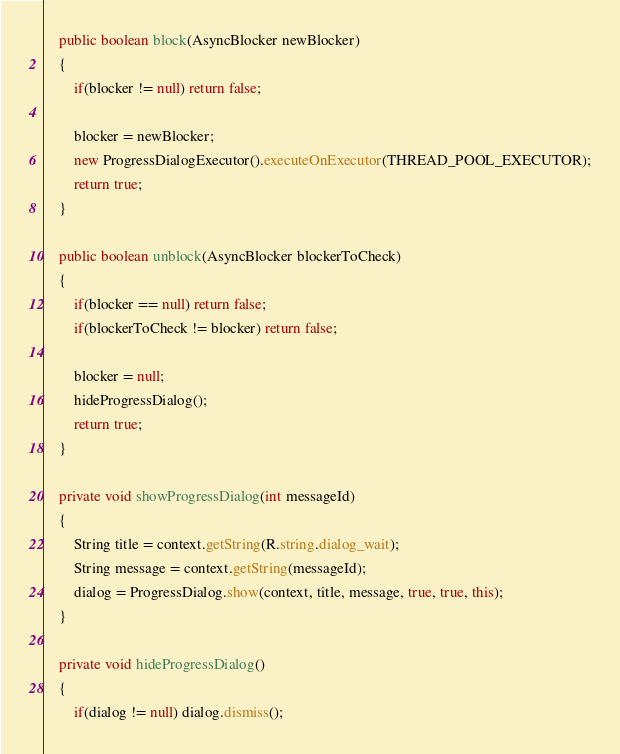<code> <loc_0><loc_0><loc_500><loc_500><_Java_>	public boolean block(AsyncBlocker newBlocker)
	{
		if(blocker != null) return false;
		
		blocker = newBlocker;
		new ProgressDialogExecutor().executeOnExecutor(THREAD_POOL_EXECUTOR);
		return true;
	}
	
	public boolean unblock(AsyncBlocker blockerToCheck)
	{
		if(blocker == null) return false;
		if(blockerToCheck != blocker) return false;
		
		blocker = null;
		hideProgressDialog();
		return true;
	}
	
	private void showProgressDialog(int messageId)
	{
		String title = context.getString(R.string.dialog_wait);
		String message = context.getString(messageId);
		dialog = ProgressDialog.show(context, title, message, true, true, this);
	}
	
	private void hideProgressDialog()
	{
		if(dialog != null) dialog.dismiss();</code> 